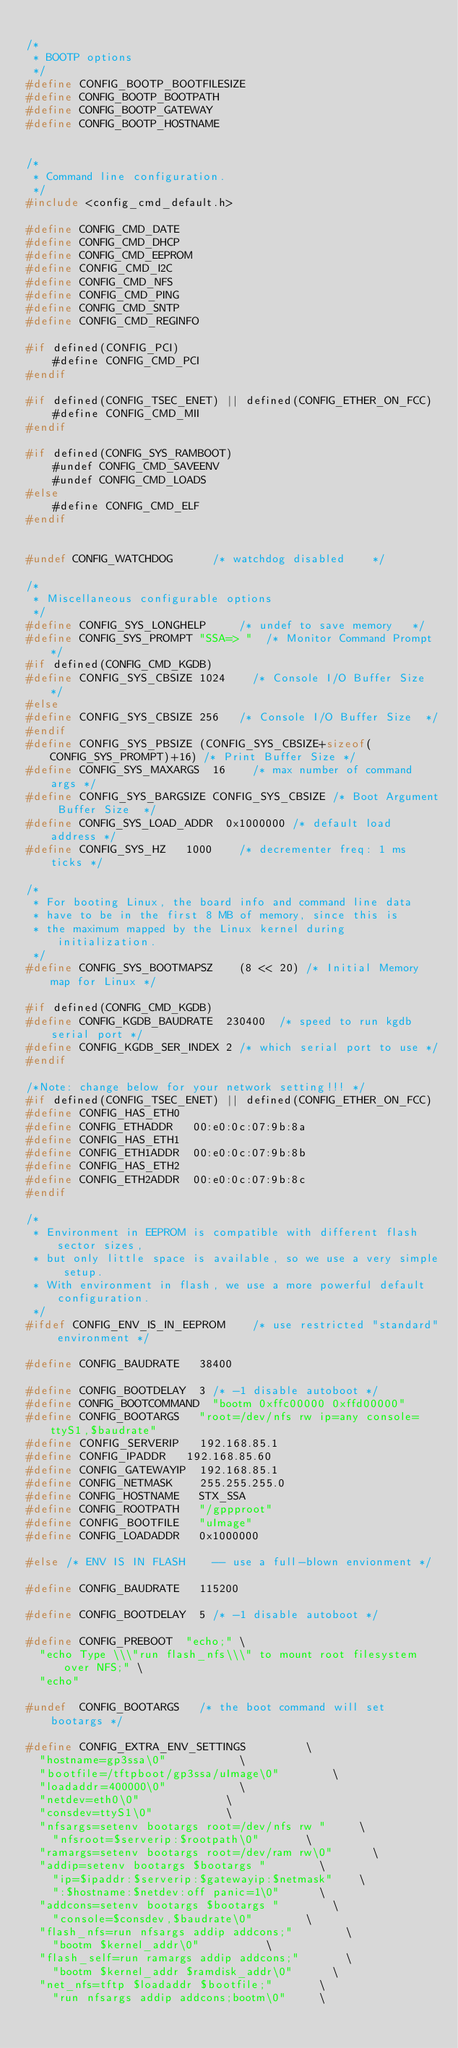Convert code to text. <code><loc_0><loc_0><loc_500><loc_500><_C_>
/*
 * BOOTP options
 */
#define CONFIG_BOOTP_BOOTFILESIZE
#define CONFIG_BOOTP_BOOTPATH
#define CONFIG_BOOTP_GATEWAY
#define CONFIG_BOOTP_HOSTNAME


/*
 * Command line configuration.
 */
#include <config_cmd_default.h>

#define CONFIG_CMD_DATE
#define CONFIG_CMD_DHCP
#define CONFIG_CMD_EEPROM
#define CONFIG_CMD_I2C
#define CONFIG_CMD_NFS
#define CONFIG_CMD_PING
#define CONFIG_CMD_SNTP
#define CONFIG_CMD_REGINFO

#if defined(CONFIG_PCI)
    #define CONFIG_CMD_PCI
#endif

#if defined(CONFIG_TSEC_ENET) || defined(CONFIG_ETHER_ON_FCC)
    #define CONFIG_CMD_MII
#endif

#if defined(CONFIG_SYS_RAMBOOT)
    #undef CONFIG_CMD_SAVEENV
    #undef CONFIG_CMD_LOADS
#else
    #define CONFIG_CMD_ELF
#endif


#undef CONFIG_WATCHDOG			/* watchdog disabled		*/

/*
 * Miscellaneous configurable options
 */
#define CONFIG_SYS_LONGHELP			/* undef to save memory		*/
#define CONFIG_SYS_PROMPT	"SSA=> "	/* Monitor Command Prompt	*/
#if defined(CONFIG_CMD_KGDB)
#define CONFIG_SYS_CBSIZE	1024		/* Console I/O Buffer Size	*/
#else
#define CONFIG_SYS_CBSIZE	256		/* Console I/O Buffer Size	*/
#endif
#define CONFIG_SYS_PBSIZE (CONFIG_SYS_CBSIZE+sizeof(CONFIG_SYS_PROMPT)+16) /* Print Buffer Size */
#define CONFIG_SYS_MAXARGS	16		/* max number of command args	*/
#define CONFIG_SYS_BARGSIZE	CONFIG_SYS_CBSIZE	/* Boot Argument Buffer Size	*/
#define CONFIG_SYS_LOAD_ADDR	0x1000000	/* default load address */
#define CONFIG_SYS_HZ		1000		/* decrementer freq: 1 ms ticks */

/*
 * For booting Linux, the board info and command line data
 * have to be in the first 8 MB of memory, since this is
 * the maximum mapped by the Linux kernel during initialization.
 */
#define CONFIG_SYS_BOOTMAPSZ		(8 << 20) /* Initial Memory map for Linux */

#if defined(CONFIG_CMD_KGDB)
#define CONFIG_KGDB_BAUDRATE	230400	/* speed to run kgdb serial port */
#define CONFIG_KGDB_SER_INDEX	2	/* which serial port to use */
#endif

/*Note: change below for your network setting!!! */
#if defined(CONFIG_TSEC_ENET) || defined(CONFIG_ETHER_ON_FCC)
#define CONFIG_HAS_ETH0
#define CONFIG_ETHADDR	 00:e0:0c:07:9b:8a
#define CONFIG_HAS_ETH1
#define CONFIG_ETH1ADDR  00:e0:0c:07:9b:8b
#define CONFIG_HAS_ETH2
#define CONFIG_ETH2ADDR  00:e0:0c:07:9b:8c
#endif

/*
 * Environment in EEPROM is compatible with different flash sector sizes,
 * but only little space is available, so we use a very simple setup.
 * With environment in flash, we use a more powerful default configuration.
 */
#ifdef CONFIG_ENV_IS_IN_EEPROM		/* use restricted "standard" environment */

#define CONFIG_BAUDRATE		38400

#define CONFIG_BOOTDELAY	3	/* -1 disable autoboot */
#define CONFIG_BOOTCOMMAND	"bootm 0xffc00000 0xffd00000"
#define CONFIG_BOOTARGS		"root=/dev/nfs rw ip=any console=ttyS1,$baudrate"
#define CONFIG_SERVERIP		192.168.85.1
#define CONFIG_IPADDR		192.168.85.60
#define CONFIG_GATEWAYIP	192.168.85.1
#define CONFIG_NETMASK		255.255.255.0
#define CONFIG_HOSTNAME		STX_SSA
#define CONFIG_ROOTPATH		"/gppproot"
#define CONFIG_BOOTFILE		"uImage"
#define CONFIG_LOADADDR		0x1000000

#else /* ENV IS IN FLASH		-- use a full-blown envionment */

#define CONFIG_BAUDRATE		115200

#define CONFIG_BOOTDELAY	5	/* -1 disable autoboot */

#define CONFIG_PREBOOT	"echo;"	\
	"echo Type \\\"run flash_nfs\\\" to mount root filesystem over NFS;" \
	"echo"

#undef	CONFIG_BOOTARGS		/* the boot command will set bootargs	*/

#define	CONFIG_EXTRA_ENV_SETTINGS					\
	"hostname=gp3ssa\0"						\
	"bootfile=/tftpboot/gp3ssa/uImage\0"				\
	"loadaddr=400000\0"						\
	"netdev=eth0\0"							\
	"consdev=ttyS1\0"						\
	"nfsargs=setenv bootargs root=/dev/nfs rw "			\
		"nfsroot=$serverip:$rootpath\0"				\
	"ramargs=setenv bootargs root=/dev/ram rw\0"			\
	"addip=setenv bootargs $bootargs "				\
		"ip=$ipaddr:$serverip:$gatewayip:$netmask"		\
		":$hostname:$netdev:off panic=1\0"			\
	"addcons=setenv bootargs $bootargs "				\
		"console=$consdev,$baudrate\0"				\
	"flash_nfs=run nfsargs addip addcons;"				\
		"bootm $kernel_addr\0"					\
	"flash_self=run ramargs addip addcons;"				\
		"bootm $kernel_addr $ramdisk_addr\0"			\
	"net_nfs=tftp $loadaddr $bootfile;"				\
		"run nfsargs addip addcons;bootm\0"			\</code> 